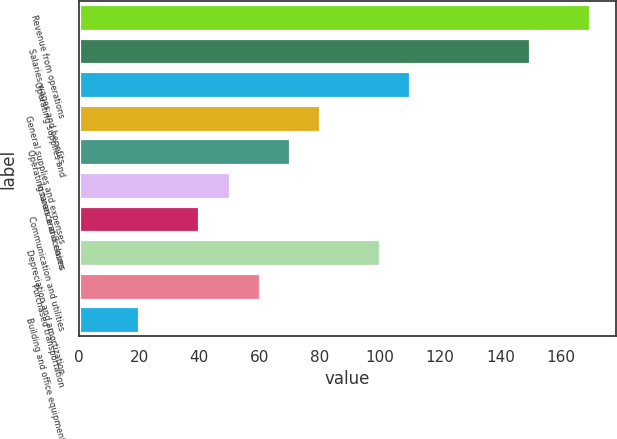<chart> <loc_0><loc_0><loc_500><loc_500><bar_chart><fcel>Revenue from operations<fcel>Salaries wages and benefits<fcel>Operating supplies and<fcel>General supplies and expenses<fcel>Operating taxes and licenses<fcel>Insurance and claims<fcel>Communication and utilities<fcel>Depreciation and amortization<fcel>Purchased transportation<fcel>Building and office equipment<nl><fcel>169.93<fcel>149.95<fcel>109.99<fcel>80.02<fcel>70.03<fcel>50.05<fcel>40.06<fcel>100<fcel>60.04<fcel>20.08<nl></chart> 